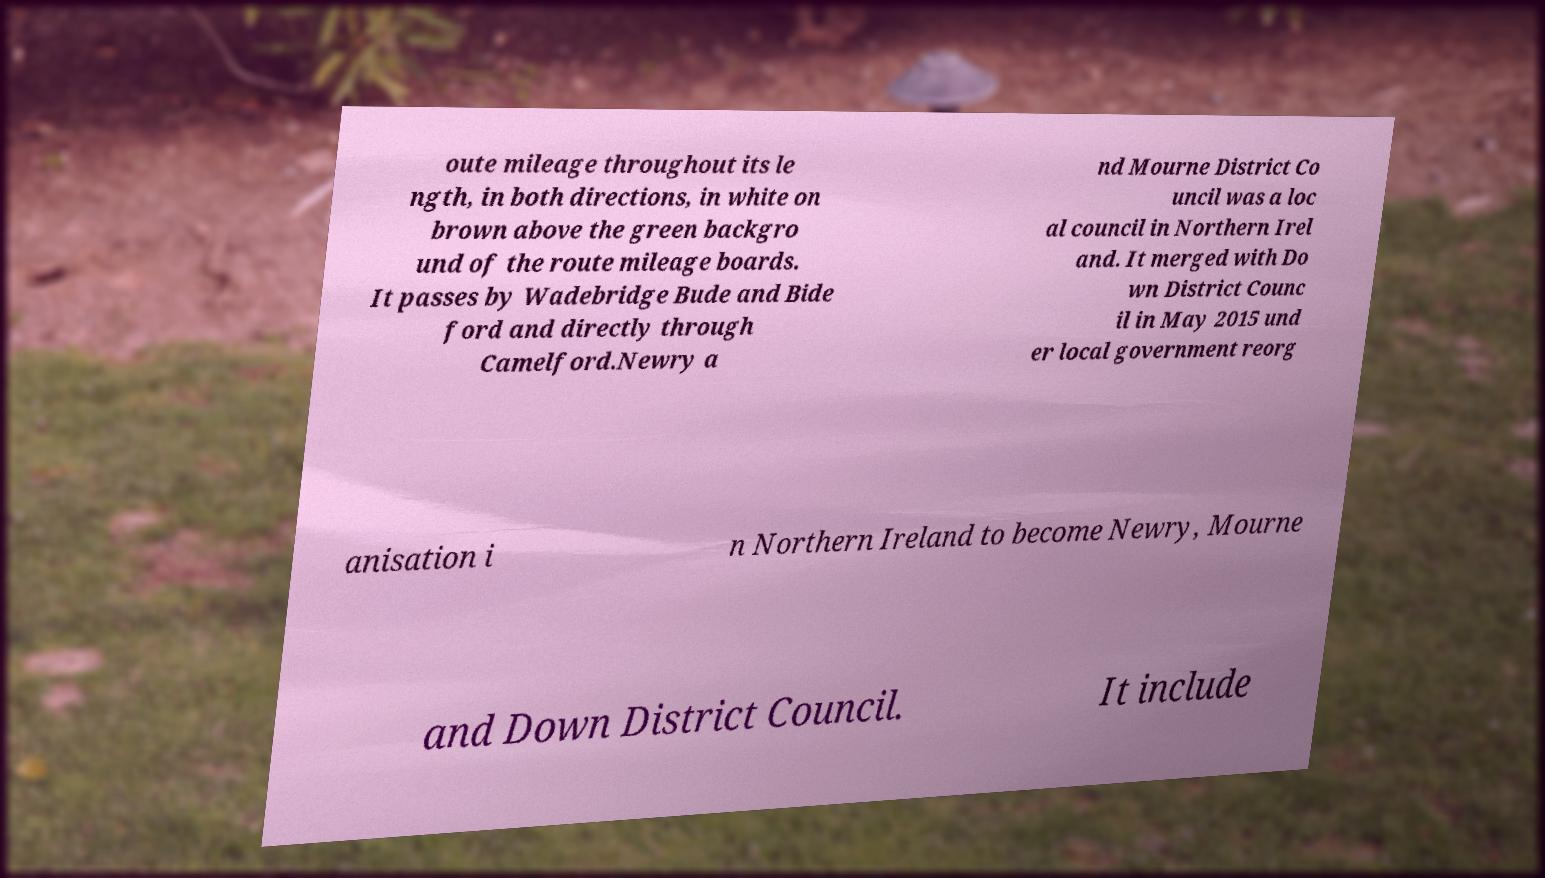Could you extract and type out the text from this image? oute mileage throughout its le ngth, in both directions, in white on brown above the green backgro und of the route mileage boards. It passes by Wadebridge Bude and Bide ford and directly through Camelford.Newry a nd Mourne District Co uncil was a loc al council in Northern Irel and. It merged with Do wn District Counc il in May 2015 und er local government reorg anisation i n Northern Ireland to become Newry, Mourne and Down District Council. It include 